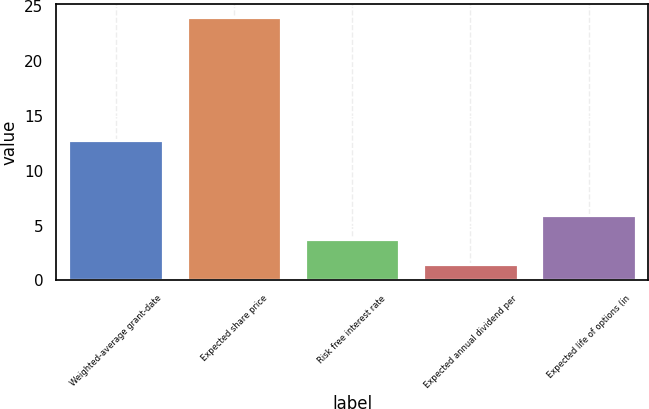<chart> <loc_0><loc_0><loc_500><loc_500><bar_chart><fcel>Weighted-average grant-date<fcel>Expected share price<fcel>Risk free interest rate<fcel>Expected annual dividend per<fcel>Expected life of options (in<nl><fcel>12.8<fcel>24<fcel>3.73<fcel>1.48<fcel>5.98<nl></chart> 